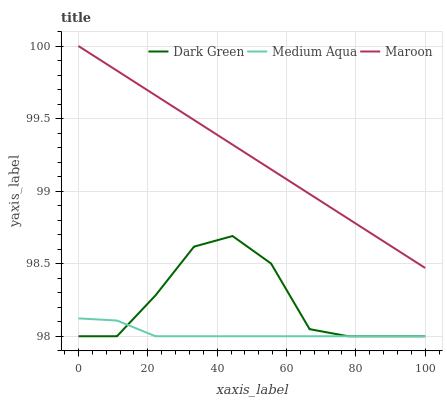Does Medium Aqua have the minimum area under the curve?
Answer yes or no. Yes. Does Maroon have the maximum area under the curve?
Answer yes or no. Yes. Does Dark Green have the minimum area under the curve?
Answer yes or no. No. Does Dark Green have the maximum area under the curve?
Answer yes or no. No. Is Maroon the smoothest?
Answer yes or no. Yes. Is Dark Green the roughest?
Answer yes or no. Yes. Is Dark Green the smoothest?
Answer yes or no. No. Is Maroon the roughest?
Answer yes or no. No. Does Medium Aqua have the lowest value?
Answer yes or no. Yes. Does Maroon have the lowest value?
Answer yes or no. No. Does Maroon have the highest value?
Answer yes or no. Yes. Does Dark Green have the highest value?
Answer yes or no. No. Is Dark Green less than Maroon?
Answer yes or no. Yes. Is Maroon greater than Medium Aqua?
Answer yes or no. Yes. Does Medium Aqua intersect Dark Green?
Answer yes or no. Yes. Is Medium Aqua less than Dark Green?
Answer yes or no. No. Is Medium Aqua greater than Dark Green?
Answer yes or no. No. Does Dark Green intersect Maroon?
Answer yes or no. No. 